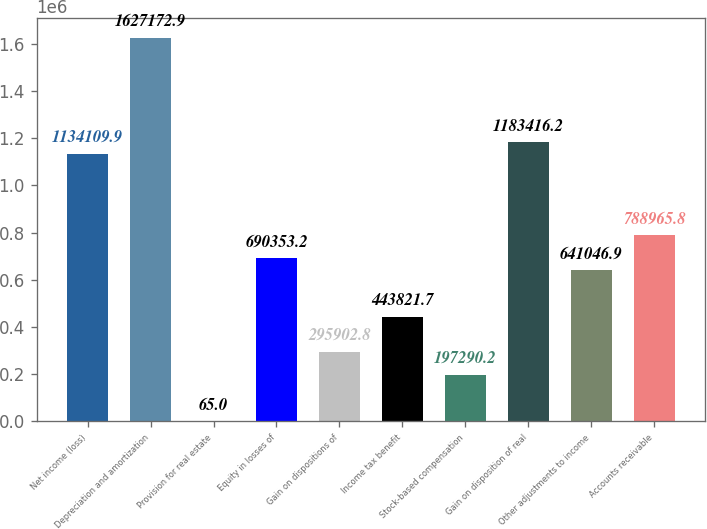<chart> <loc_0><loc_0><loc_500><loc_500><bar_chart><fcel>Net income (loss)<fcel>Depreciation and amortization<fcel>Provision for real estate<fcel>Equity in losses of<fcel>Gain on dispositions of<fcel>Income tax benefit<fcel>Stock-based compensation<fcel>Gain on disposition of real<fcel>Other adjustments to income<fcel>Accounts receivable<nl><fcel>1.13411e+06<fcel>1.62717e+06<fcel>65<fcel>690353<fcel>295903<fcel>443822<fcel>197290<fcel>1.18342e+06<fcel>641047<fcel>788966<nl></chart> 